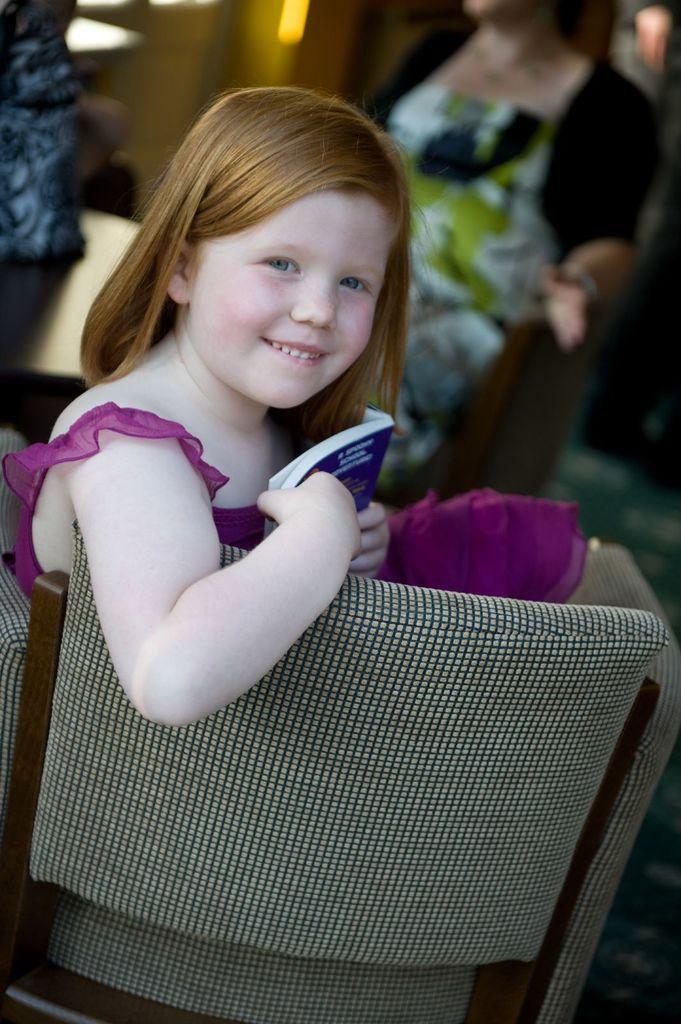Can you describe this image briefly? In this image I can see a girl wearing a red color gown ,she smiling and she holding book and she sit on the chair back side of her there are some persons standing 